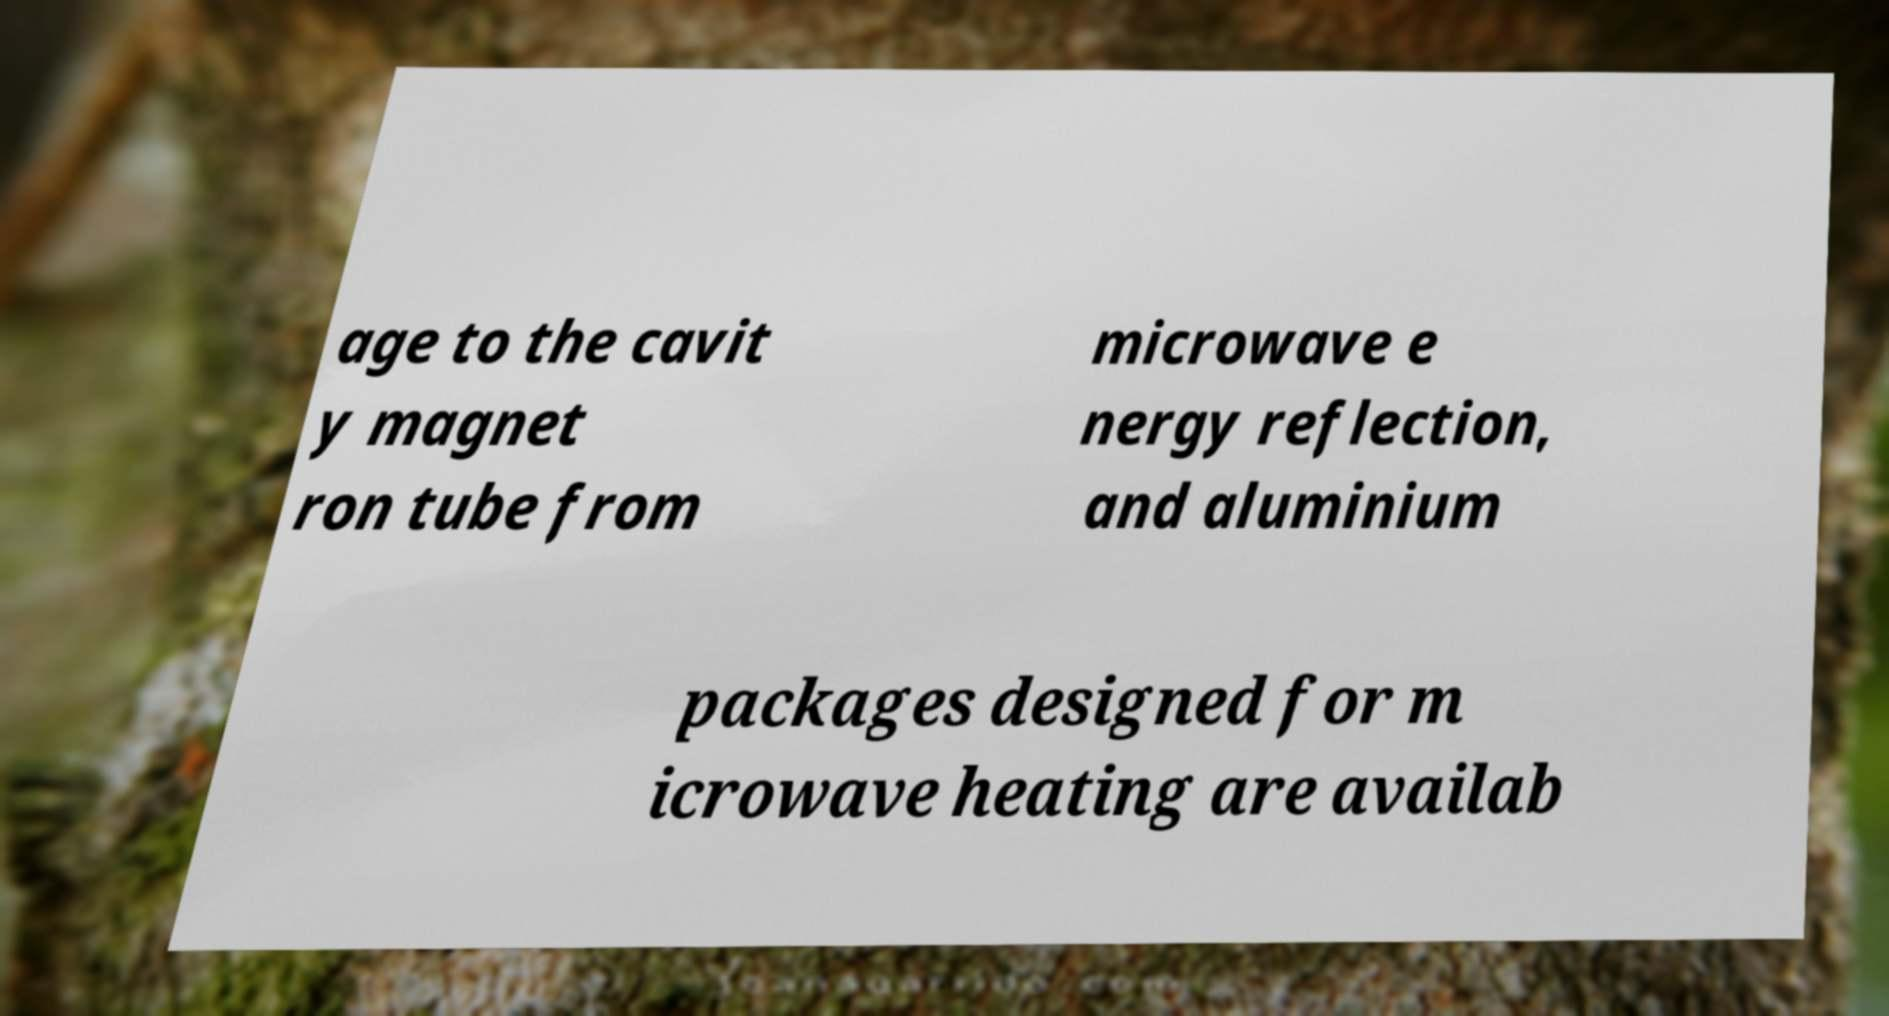Can you read and provide the text displayed in the image?This photo seems to have some interesting text. Can you extract and type it out for me? age to the cavit y magnet ron tube from microwave e nergy reflection, and aluminium packages designed for m icrowave heating are availab 